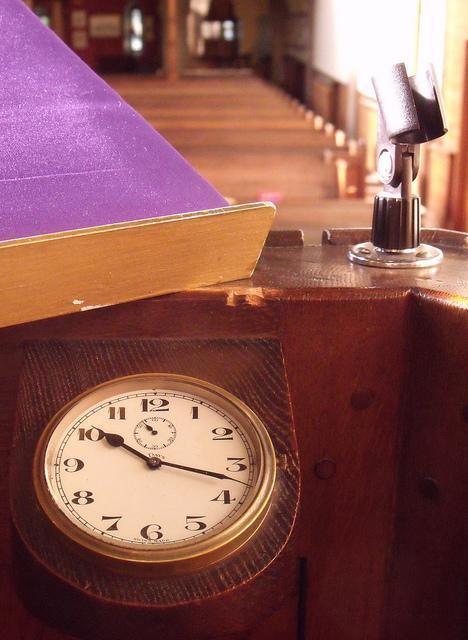How many clocks are there?
Give a very brief answer. 1. 